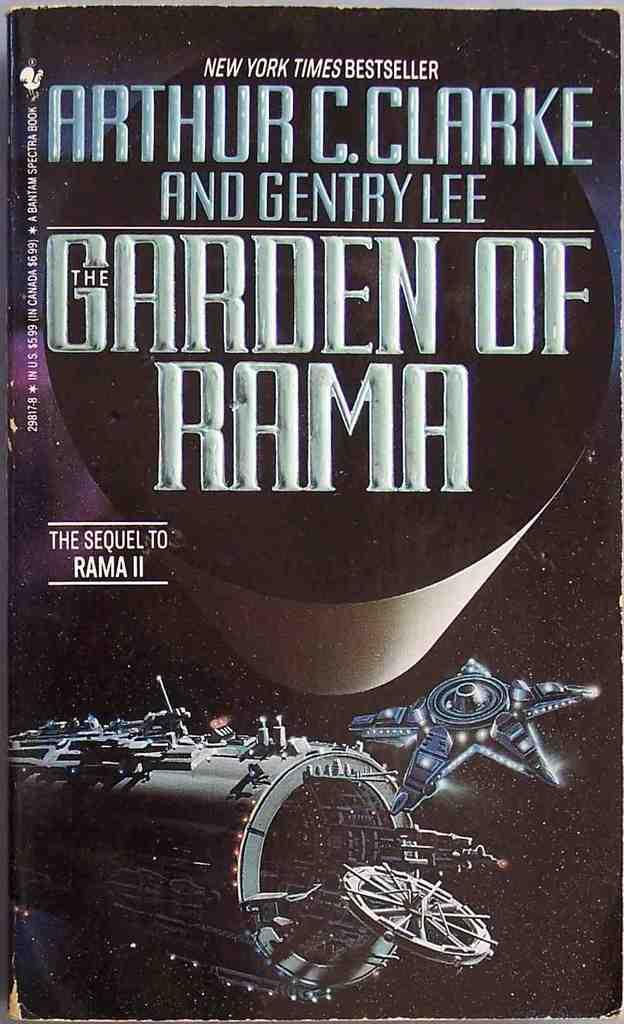<image>
Provide a brief description of the given image. The front cover of the book Garden of Rama by Arthur C. Clarke. 